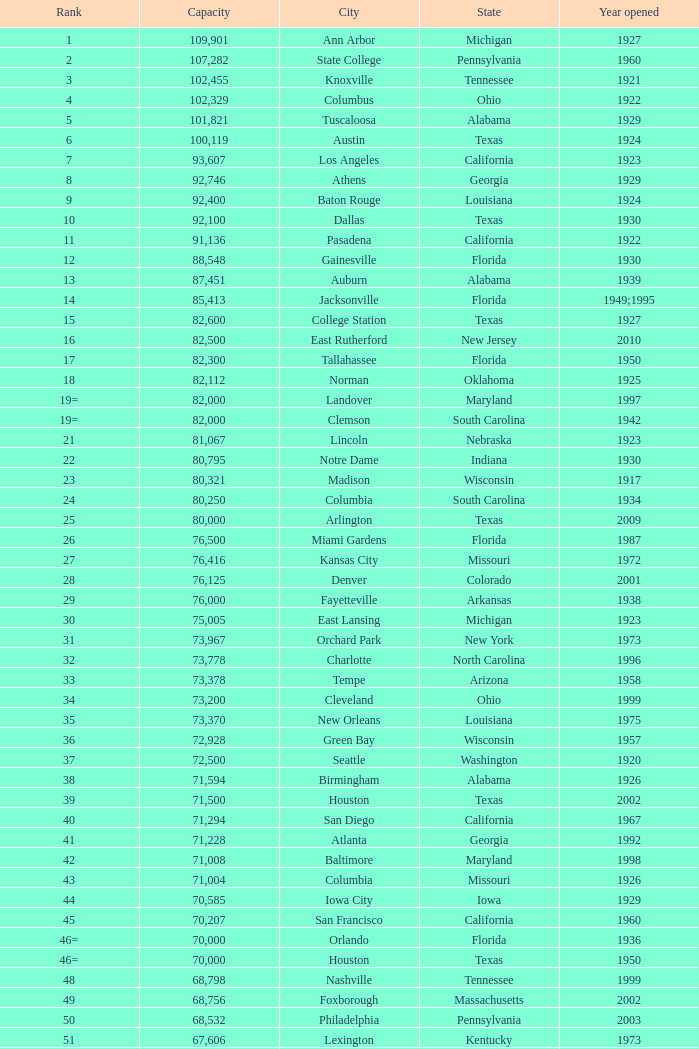In alabama, what city was founded in 1996? Huntsville. 